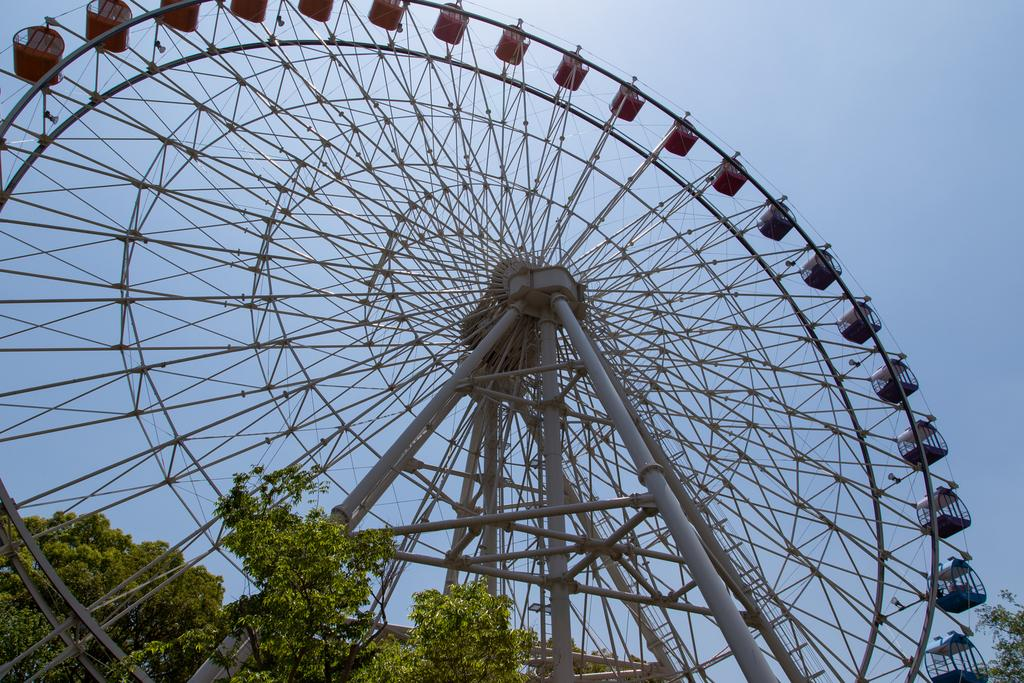What can be seen in the front of the image? There are trees in the front of the image. What is the main feature in the center of the image? There is a giant wheel in the center of the image. What is visible in the background of the image? There are trees in the background of the image. What type of hat is the letter wearing in the image? There is no hat or letter present in the image. What is the giant wheel serving for breakfast in the image? There is no breakfast or giant wheel serving food in the image. 